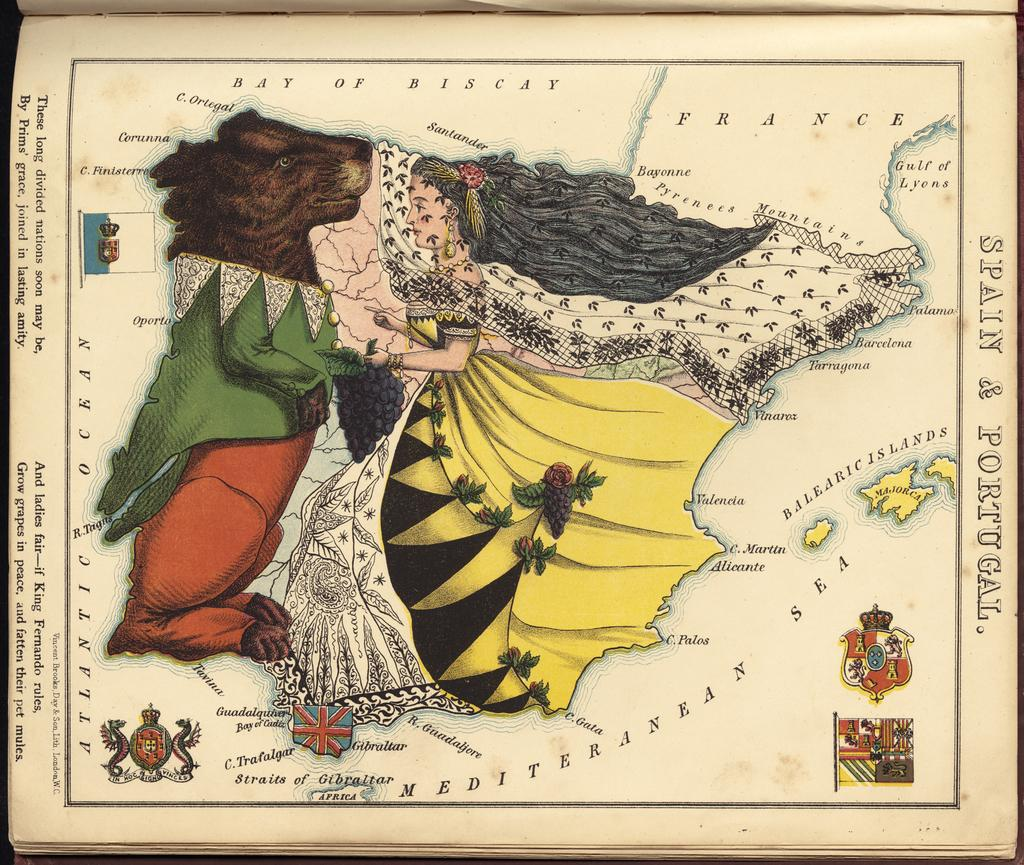What is the main subject of the image? There is a painting in the image. What is depicted in the painting? The painting depicts persons. Are there any additional elements in the painting besides the persons? Yes, there is text written on the painting. How many geese are flying in the middle of the painting? There are no geese present in the painting; it depicts persons and text. What type of joke is written on the painting? There is no joke written on the painting; it contains text, but the content is not specified. 